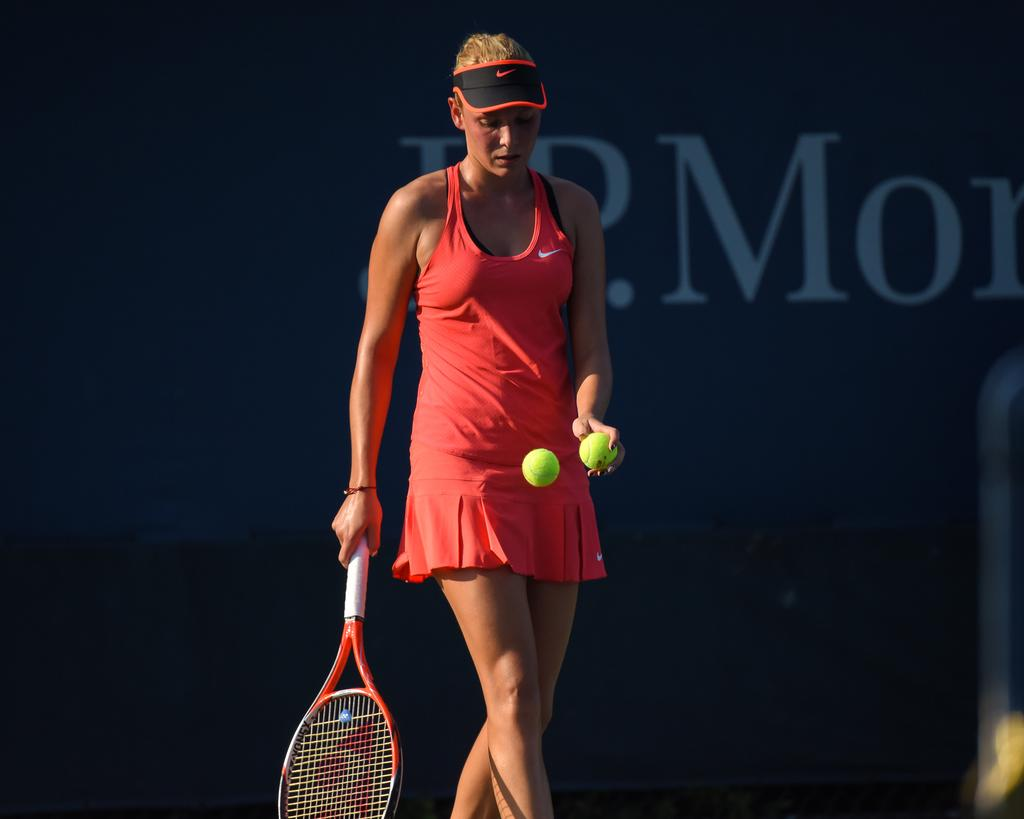Who is the main subject in the image? There is a woman in the image. What is the woman doing in the image? The woman is a tennis player and is preparing to give a service. What type of tramp can be seen in the image? There is no tramp present in the image; it features a woman preparing to give a service in tennis. 